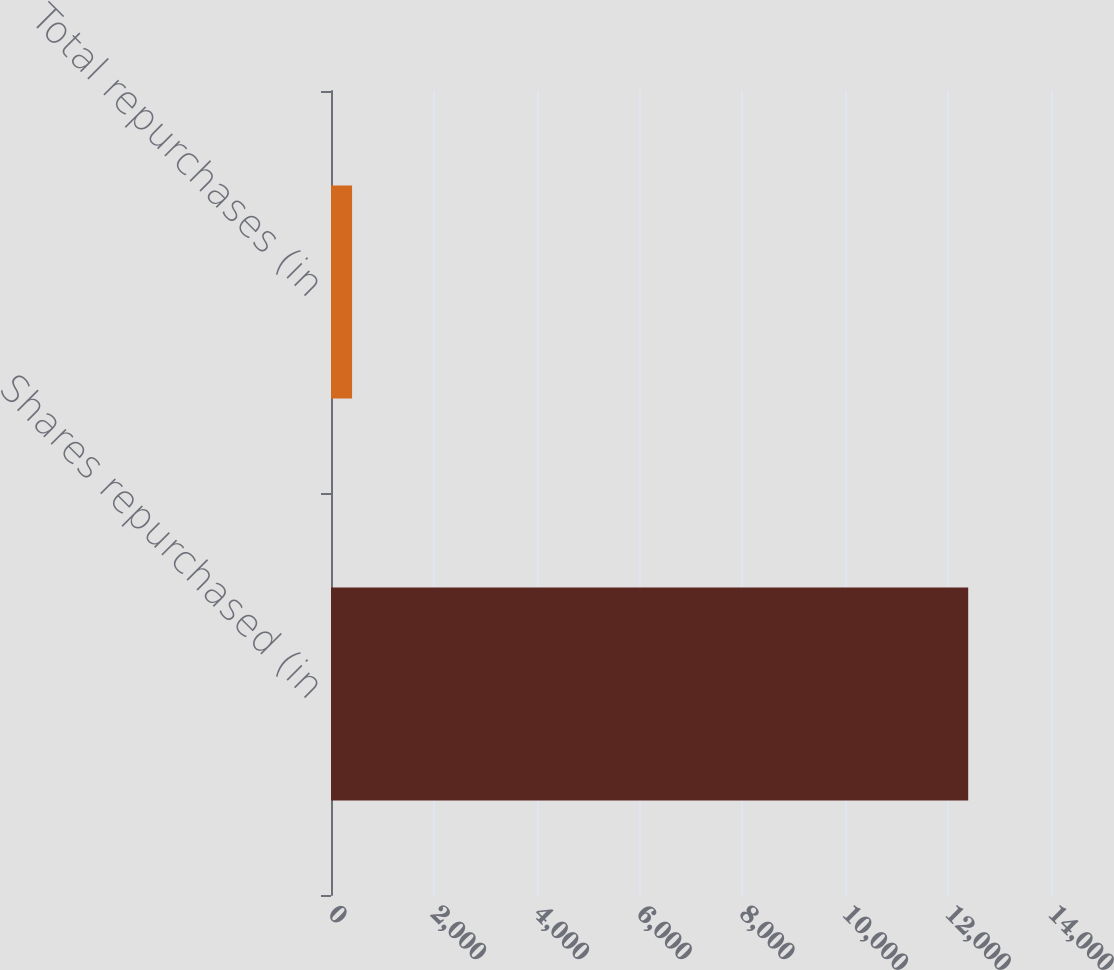Convert chart. <chart><loc_0><loc_0><loc_500><loc_500><bar_chart><fcel>Shares repurchased (in<fcel>Total repurchases (in<nl><fcel>12390<fcel>410<nl></chart> 